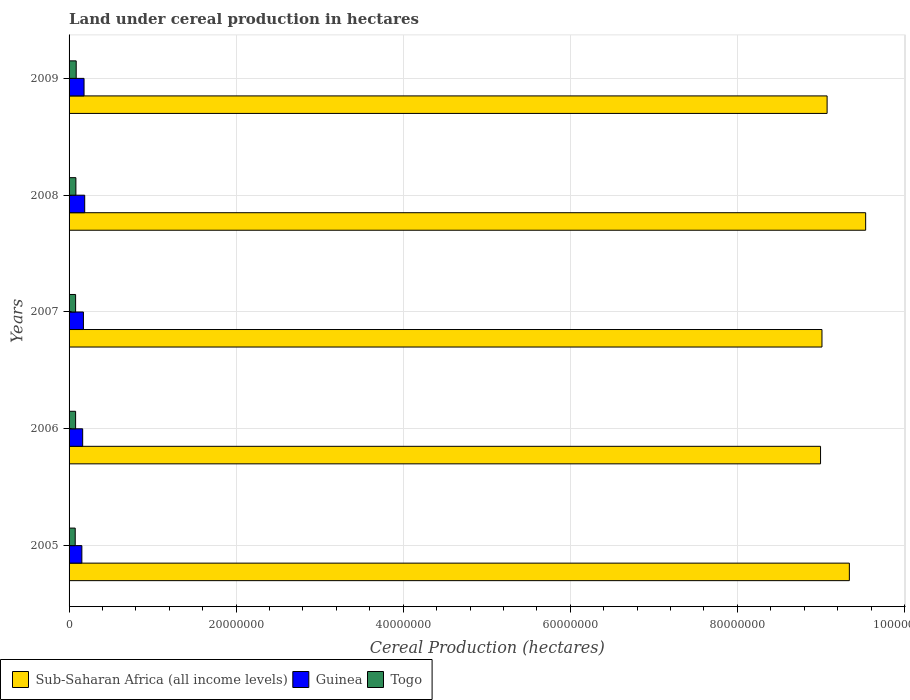How many groups of bars are there?
Your response must be concise. 5. Are the number of bars per tick equal to the number of legend labels?
Your answer should be very brief. Yes. Are the number of bars on each tick of the Y-axis equal?
Provide a short and direct response. Yes. How many bars are there on the 5th tick from the top?
Make the answer very short. 3. What is the land under cereal production in Sub-Saharan Africa (all income levels) in 2006?
Make the answer very short. 9.00e+07. Across all years, what is the maximum land under cereal production in Sub-Saharan Africa (all income levels)?
Your response must be concise. 9.54e+07. Across all years, what is the minimum land under cereal production in Guinea?
Give a very brief answer. 1.53e+06. In which year was the land under cereal production in Guinea maximum?
Your answer should be very brief. 2008. What is the total land under cereal production in Togo in the graph?
Your answer should be compact. 3.97e+06. What is the difference between the land under cereal production in Sub-Saharan Africa (all income levels) in 2007 and that in 2008?
Your answer should be very brief. -5.23e+06. What is the difference between the land under cereal production in Guinea in 2006 and the land under cereal production in Sub-Saharan Africa (all income levels) in 2009?
Your answer should be compact. -8.91e+07. What is the average land under cereal production in Guinea per year?
Ensure brevity in your answer.  1.71e+06. In the year 2005, what is the difference between the land under cereal production in Togo and land under cereal production in Guinea?
Provide a short and direct response. -7.95e+05. In how many years, is the land under cereal production in Guinea greater than 88000000 hectares?
Ensure brevity in your answer.  0. What is the ratio of the land under cereal production in Togo in 2005 to that in 2009?
Ensure brevity in your answer.  0.86. What is the difference between the highest and the second highest land under cereal production in Sub-Saharan Africa (all income levels)?
Ensure brevity in your answer.  1.95e+06. What is the difference between the highest and the lowest land under cereal production in Togo?
Keep it short and to the point. 1.18e+05. Is the sum of the land under cereal production in Togo in 2005 and 2008 greater than the maximum land under cereal production in Guinea across all years?
Ensure brevity in your answer.  No. What does the 3rd bar from the top in 2006 represents?
Give a very brief answer. Sub-Saharan Africa (all income levels). What does the 2nd bar from the bottom in 2006 represents?
Your answer should be compact. Guinea. How many years are there in the graph?
Provide a succinct answer. 5. Does the graph contain grids?
Provide a short and direct response. Yes. Where does the legend appear in the graph?
Make the answer very short. Bottom left. How are the legend labels stacked?
Offer a very short reply. Horizontal. What is the title of the graph?
Offer a terse response. Land under cereal production in hectares. Does "Romania" appear as one of the legend labels in the graph?
Make the answer very short. No. What is the label or title of the X-axis?
Provide a succinct answer. Cereal Production (hectares). What is the Cereal Production (hectares) of Sub-Saharan Africa (all income levels) in 2005?
Give a very brief answer. 9.34e+07. What is the Cereal Production (hectares) in Guinea in 2005?
Give a very brief answer. 1.53e+06. What is the Cereal Production (hectares) of Togo in 2005?
Offer a terse response. 7.36e+05. What is the Cereal Production (hectares) of Sub-Saharan Africa (all income levels) in 2006?
Keep it short and to the point. 9.00e+07. What is the Cereal Production (hectares) in Guinea in 2006?
Your response must be concise. 1.63e+06. What is the Cereal Production (hectares) in Togo in 2006?
Provide a short and direct response. 7.83e+05. What is the Cereal Production (hectares) in Sub-Saharan Africa (all income levels) in 2007?
Your answer should be very brief. 9.01e+07. What is the Cereal Production (hectares) in Guinea in 2007?
Offer a very short reply. 1.72e+06. What is the Cereal Production (hectares) in Togo in 2007?
Provide a succinct answer. 7.82e+05. What is the Cereal Production (hectares) of Sub-Saharan Africa (all income levels) in 2008?
Your response must be concise. 9.54e+07. What is the Cereal Production (hectares) of Guinea in 2008?
Your answer should be very brief. 1.87e+06. What is the Cereal Production (hectares) of Togo in 2008?
Your answer should be very brief. 8.17e+05. What is the Cereal Production (hectares) of Sub-Saharan Africa (all income levels) in 2009?
Your response must be concise. 9.07e+07. What is the Cereal Production (hectares) in Guinea in 2009?
Your answer should be compact. 1.79e+06. What is the Cereal Production (hectares) of Togo in 2009?
Give a very brief answer. 8.54e+05. Across all years, what is the maximum Cereal Production (hectares) of Sub-Saharan Africa (all income levels)?
Ensure brevity in your answer.  9.54e+07. Across all years, what is the maximum Cereal Production (hectares) of Guinea?
Your answer should be compact. 1.87e+06. Across all years, what is the maximum Cereal Production (hectares) of Togo?
Give a very brief answer. 8.54e+05. Across all years, what is the minimum Cereal Production (hectares) of Sub-Saharan Africa (all income levels)?
Your answer should be compact. 9.00e+07. Across all years, what is the minimum Cereal Production (hectares) of Guinea?
Give a very brief answer. 1.53e+06. Across all years, what is the minimum Cereal Production (hectares) in Togo?
Offer a very short reply. 7.36e+05. What is the total Cereal Production (hectares) in Sub-Saharan Africa (all income levels) in the graph?
Your answer should be compact. 4.60e+08. What is the total Cereal Production (hectares) of Guinea in the graph?
Offer a very short reply. 8.54e+06. What is the total Cereal Production (hectares) of Togo in the graph?
Your answer should be very brief. 3.97e+06. What is the difference between the Cereal Production (hectares) of Sub-Saharan Africa (all income levels) in 2005 and that in 2006?
Give a very brief answer. 3.45e+06. What is the difference between the Cereal Production (hectares) of Guinea in 2005 and that in 2006?
Make the answer very short. -9.67e+04. What is the difference between the Cereal Production (hectares) of Togo in 2005 and that in 2006?
Ensure brevity in your answer.  -4.74e+04. What is the difference between the Cereal Production (hectares) of Sub-Saharan Africa (all income levels) in 2005 and that in 2007?
Keep it short and to the point. 3.28e+06. What is the difference between the Cereal Production (hectares) in Guinea in 2005 and that in 2007?
Your answer should be compact. -1.87e+05. What is the difference between the Cereal Production (hectares) of Togo in 2005 and that in 2007?
Give a very brief answer. -4.67e+04. What is the difference between the Cereal Production (hectares) in Sub-Saharan Africa (all income levels) in 2005 and that in 2008?
Provide a succinct answer. -1.95e+06. What is the difference between the Cereal Production (hectares) in Guinea in 2005 and that in 2008?
Keep it short and to the point. -3.41e+05. What is the difference between the Cereal Production (hectares) of Togo in 2005 and that in 2008?
Your response must be concise. -8.14e+04. What is the difference between the Cereal Production (hectares) of Sub-Saharan Africa (all income levels) in 2005 and that in 2009?
Provide a succinct answer. 2.66e+06. What is the difference between the Cereal Production (hectares) of Guinea in 2005 and that in 2009?
Your response must be concise. -2.61e+05. What is the difference between the Cereal Production (hectares) in Togo in 2005 and that in 2009?
Your response must be concise. -1.18e+05. What is the difference between the Cereal Production (hectares) of Sub-Saharan Africa (all income levels) in 2006 and that in 2007?
Keep it short and to the point. -1.70e+05. What is the difference between the Cereal Production (hectares) of Guinea in 2006 and that in 2007?
Provide a succinct answer. -9.02e+04. What is the difference between the Cereal Production (hectares) of Togo in 2006 and that in 2007?
Provide a short and direct response. 667. What is the difference between the Cereal Production (hectares) in Sub-Saharan Africa (all income levels) in 2006 and that in 2008?
Provide a short and direct response. -5.40e+06. What is the difference between the Cereal Production (hectares) in Guinea in 2006 and that in 2008?
Make the answer very short. -2.44e+05. What is the difference between the Cereal Production (hectares) in Togo in 2006 and that in 2008?
Your response must be concise. -3.40e+04. What is the difference between the Cereal Production (hectares) in Sub-Saharan Africa (all income levels) in 2006 and that in 2009?
Your response must be concise. -7.85e+05. What is the difference between the Cereal Production (hectares) of Guinea in 2006 and that in 2009?
Your answer should be very brief. -1.64e+05. What is the difference between the Cereal Production (hectares) of Togo in 2006 and that in 2009?
Offer a very short reply. -7.08e+04. What is the difference between the Cereal Production (hectares) of Sub-Saharan Africa (all income levels) in 2007 and that in 2008?
Offer a very short reply. -5.23e+06. What is the difference between the Cereal Production (hectares) of Guinea in 2007 and that in 2008?
Your answer should be very brief. -1.54e+05. What is the difference between the Cereal Production (hectares) in Togo in 2007 and that in 2008?
Ensure brevity in your answer.  -3.47e+04. What is the difference between the Cereal Production (hectares) of Sub-Saharan Africa (all income levels) in 2007 and that in 2009?
Provide a succinct answer. -6.15e+05. What is the difference between the Cereal Production (hectares) of Guinea in 2007 and that in 2009?
Your response must be concise. -7.39e+04. What is the difference between the Cereal Production (hectares) in Togo in 2007 and that in 2009?
Ensure brevity in your answer.  -7.15e+04. What is the difference between the Cereal Production (hectares) in Sub-Saharan Africa (all income levels) in 2008 and that in 2009?
Make the answer very short. 4.62e+06. What is the difference between the Cereal Production (hectares) in Guinea in 2008 and that in 2009?
Your answer should be very brief. 7.99e+04. What is the difference between the Cereal Production (hectares) in Togo in 2008 and that in 2009?
Provide a short and direct response. -3.68e+04. What is the difference between the Cereal Production (hectares) in Sub-Saharan Africa (all income levels) in 2005 and the Cereal Production (hectares) in Guinea in 2006?
Give a very brief answer. 9.18e+07. What is the difference between the Cereal Production (hectares) in Sub-Saharan Africa (all income levels) in 2005 and the Cereal Production (hectares) in Togo in 2006?
Ensure brevity in your answer.  9.26e+07. What is the difference between the Cereal Production (hectares) of Guinea in 2005 and the Cereal Production (hectares) of Togo in 2006?
Your answer should be compact. 7.48e+05. What is the difference between the Cereal Production (hectares) in Sub-Saharan Africa (all income levels) in 2005 and the Cereal Production (hectares) in Guinea in 2007?
Your answer should be very brief. 9.17e+07. What is the difference between the Cereal Production (hectares) in Sub-Saharan Africa (all income levels) in 2005 and the Cereal Production (hectares) in Togo in 2007?
Provide a succinct answer. 9.26e+07. What is the difference between the Cereal Production (hectares) in Guinea in 2005 and the Cereal Production (hectares) in Togo in 2007?
Give a very brief answer. 7.49e+05. What is the difference between the Cereal Production (hectares) in Sub-Saharan Africa (all income levels) in 2005 and the Cereal Production (hectares) in Guinea in 2008?
Ensure brevity in your answer.  9.15e+07. What is the difference between the Cereal Production (hectares) of Sub-Saharan Africa (all income levels) in 2005 and the Cereal Production (hectares) of Togo in 2008?
Your answer should be compact. 9.26e+07. What is the difference between the Cereal Production (hectares) in Guinea in 2005 and the Cereal Production (hectares) in Togo in 2008?
Keep it short and to the point. 7.14e+05. What is the difference between the Cereal Production (hectares) of Sub-Saharan Africa (all income levels) in 2005 and the Cereal Production (hectares) of Guinea in 2009?
Ensure brevity in your answer.  9.16e+07. What is the difference between the Cereal Production (hectares) of Sub-Saharan Africa (all income levels) in 2005 and the Cereal Production (hectares) of Togo in 2009?
Ensure brevity in your answer.  9.26e+07. What is the difference between the Cereal Production (hectares) in Guinea in 2005 and the Cereal Production (hectares) in Togo in 2009?
Ensure brevity in your answer.  6.77e+05. What is the difference between the Cereal Production (hectares) of Sub-Saharan Africa (all income levels) in 2006 and the Cereal Production (hectares) of Guinea in 2007?
Ensure brevity in your answer.  8.82e+07. What is the difference between the Cereal Production (hectares) in Sub-Saharan Africa (all income levels) in 2006 and the Cereal Production (hectares) in Togo in 2007?
Ensure brevity in your answer.  8.92e+07. What is the difference between the Cereal Production (hectares) of Guinea in 2006 and the Cereal Production (hectares) of Togo in 2007?
Give a very brief answer. 8.45e+05. What is the difference between the Cereal Production (hectares) of Sub-Saharan Africa (all income levels) in 2006 and the Cereal Production (hectares) of Guinea in 2008?
Ensure brevity in your answer.  8.81e+07. What is the difference between the Cereal Production (hectares) of Sub-Saharan Africa (all income levels) in 2006 and the Cereal Production (hectares) of Togo in 2008?
Give a very brief answer. 8.91e+07. What is the difference between the Cereal Production (hectares) in Guinea in 2006 and the Cereal Production (hectares) in Togo in 2008?
Your answer should be very brief. 8.11e+05. What is the difference between the Cereal Production (hectares) of Sub-Saharan Africa (all income levels) in 2006 and the Cereal Production (hectares) of Guinea in 2009?
Provide a succinct answer. 8.82e+07. What is the difference between the Cereal Production (hectares) in Sub-Saharan Africa (all income levels) in 2006 and the Cereal Production (hectares) in Togo in 2009?
Provide a short and direct response. 8.91e+07. What is the difference between the Cereal Production (hectares) of Guinea in 2006 and the Cereal Production (hectares) of Togo in 2009?
Provide a succinct answer. 7.74e+05. What is the difference between the Cereal Production (hectares) of Sub-Saharan Africa (all income levels) in 2007 and the Cereal Production (hectares) of Guinea in 2008?
Make the answer very short. 8.83e+07. What is the difference between the Cereal Production (hectares) of Sub-Saharan Africa (all income levels) in 2007 and the Cereal Production (hectares) of Togo in 2008?
Offer a very short reply. 8.93e+07. What is the difference between the Cereal Production (hectares) in Guinea in 2007 and the Cereal Production (hectares) in Togo in 2008?
Ensure brevity in your answer.  9.01e+05. What is the difference between the Cereal Production (hectares) of Sub-Saharan Africa (all income levels) in 2007 and the Cereal Production (hectares) of Guinea in 2009?
Your response must be concise. 8.83e+07. What is the difference between the Cereal Production (hectares) of Sub-Saharan Africa (all income levels) in 2007 and the Cereal Production (hectares) of Togo in 2009?
Your response must be concise. 8.93e+07. What is the difference between the Cereal Production (hectares) of Guinea in 2007 and the Cereal Production (hectares) of Togo in 2009?
Offer a terse response. 8.64e+05. What is the difference between the Cereal Production (hectares) of Sub-Saharan Africa (all income levels) in 2008 and the Cereal Production (hectares) of Guinea in 2009?
Your response must be concise. 9.36e+07. What is the difference between the Cereal Production (hectares) of Sub-Saharan Africa (all income levels) in 2008 and the Cereal Production (hectares) of Togo in 2009?
Offer a terse response. 9.45e+07. What is the difference between the Cereal Production (hectares) of Guinea in 2008 and the Cereal Production (hectares) of Togo in 2009?
Offer a terse response. 1.02e+06. What is the average Cereal Production (hectares) in Sub-Saharan Africa (all income levels) per year?
Offer a terse response. 9.19e+07. What is the average Cereal Production (hectares) of Guinea per year?
Offer a terse response. 1.71e+06. What is the average Cereal Production (hectares) of Togo per year?
Make the answer very short. 7.95e+05. In the year 2005, what is the difference between the Cereal Production (hectares) of Sub-Saharan Africa (all income levels) and Cereal Production (hectares) of Guinea?
Your response must be concise. 9.19e+07. In the year 2005, what is the difference between the Cereal Production (hectares) in Sub-Saharan Africa (all income levels) and Cereal Production (hectares) in Togo?
Keep it short and to the point. 9.27e+07. In the year 2005, what is the difference between the Cereal Production (hectares) of Guinea and Cereal Production (hectares) of Togo?
Your answer should be compact. 7.95e+05. In the year 2006, what is the difference between the Cereal Production (hectares) in Sub-Saharan Africa (all income levels) and Cereal Production (hectares) in Guinea?
Provide a short and direct response. 8.83e+07. In the year 2006, what is the difference between the Cereal Production (hectares) of Sub-Saharan Africa (all income levels) and Cereal Production (hectares) of Togo?
Ensure brevity in your answer.  8.92e+07. In the year 2006, what is the difference between the Cereal Production (hectares) in Guinea and Cereal Production (hectares) in Togo?
Keep it short and to the point. 8.45e+05. In the year 2007, what is the difference between the Cereal Production (hectares) of Sub-Saharan Africa (all income levels) and Cereal Production (hectares) of Guinea?
Keep it short and to the point. 8.84e+07. In the year 2007, what is the difference between the Cereal Production (hectares) of Sub-Saharan Africa (all income levels) and Cereal Production (hectares) of Togo?
Give a very brief answer. 8.93e+07. In the year 2007, what is the difference between the Cereal Production (hectares) of Guinea and Cereal Production (hectares) of Togo?
Your answer should be very brief. 9.36e+05. In the year 2008, what is the difference between the Cereal Production (hectares) of Sub-Saharan Africa (all income levels) and Cereal Production (hectares) of Guinea?
Your answer should be compact. 9.35e+07. In the year 2008, what is the difference between the Cereal Production (hectares) of Sub-Saharan Africa (all income levels) and Cereal Production (hectares) of Togo?
Your answer should be very brief. 9.45e+07. In the year 2008, what is the difference between the Cereal Production (hectares) in Guinea and Cereal Production (hectares) in Togo?
Offer a terse response. 1.05e+06. In the year 2009, what is the difference between the Cereal Production (hectares) of Sub-Saharan Africa (all income levels) and Cereal Production (hectares) of Guinea?
Provide a succinct answer. 8.89e+07. In the year 2009, what is the difference between the Cereal Production (hectares) in Sub-Saharan Africa (all income levels) and Cereal Production (hectares) in Togo?
Your response must be concise. 8.99e+07. In the year 2009, what is the difference between the Cereal Production (hectares) of Guinea and Cereal Production (hectares) of Togo?
Give a very brief answer. 9.38e+05. What is the ratio of the Cereal Production (hectares) in Sub-Saharan Africa (all income levels) in 2005 to that in 2006?
Your answer should be very brief. 1.04. What is the ratio of the Cereal Production (hectares) in Guinea in 2005 to that in 2006?
Keep it short and to the point. 0.94. What is the ratio of the Cereal Production (hectares) in Togo in 2005 to that in 2006?
Your response must be concise. 0.94. What is the ratio of the Cereal Production (hectares) in Sub-Saharan Africa (all income levels) in 2005 to that in 2007?
Offer a terse response. 1.04. What is the ratio of the Cereal Production (hectares) of Guinea in 2005 to that in 2007?
Your answer should be very brief. 0.89. What is the ratio of the Cereal Production (hectares) of Togo in 2005 to that in 2007?
Give a very brief answer. 0.94. What is the ratio of the Cereal Production (hectares) of Sub-Saharan Africa (all income levels) in 2005 to that in 2008?
Your response must be concise. 0.98. What is the ratio of the Cereal Production (hectares) of Guinea in 2005 to that in 2008?
Give a very brief answer. 0.82. What is the ratio of the Cereal Production (hectares) in Togo in 2005 to that in 2008?
Your answer should be very brief. 0.9. What is the ratio of the Cereal Production (hectares) in Sub-Saharan Africa (all income levels) in 2005 to that in 2009?
Offer a terse response. 1.03. What is the ratio of the Cereal Production (hectares) of Guinea in 2005 to that in 2009?
Offer a terse response. 0.85. What is the ratio of the Cereal Production (hectares) in Togo in 2005 to that in 2009?
Keep it short and to the point. 0.86. What is the ratio of the Cereal Production (hectares) of Sub-Saharan Africa (all income levels) in 2006 to that in 2007?
Give a very brief answer. 1. What is the ratio of the Cereal Production (hectares) of Guinea in 2006 to that in 2007?
Provide a succinct answer. 0.95. What is the ratio of the Cereal Production (hectares) of Sub-Saharan Africa (all income levels) in 2006 to that in 2008?
Your answer should be compact. 0.94. What is the ratio of the Cereal Production (hectares) in Guinea in 2006 to that in 2008?
Ensure brevity in your answer.  0.87. What is the ratio of the Cereal Production (hectares) in Togo in 2006 to that in 2008?
Offer a very short reply. 0.96. What is the ratio of the Cereal Production (hectares) in Guinea in 2006 to that in 2009?
Provide a succinct answer. 0.91. What is the ratio of the Cereal Production (hectares) in Togo in 2006 to that in 2009?
Provide a succinct answer. 0.92. What is the ratio of the Cereal Production (hectares) in Sub-Saharan Africa (all income levels) in 2007 to that in 2008?
Ensure brevity in your answer.  0.95. What is the ratio of the Cereal Production (hectares) of Guinea in 2007 to that in 2008?
Your answer should be compact. 0.92. What is the ratio of the Cereal Production (hectares) of Togo in 2007 to that in 2008?
Make the answer very short. 0.96. What is the ratio of the Cereal Production (hectares) in Guinea in 2007 to that in 2009?
Your answer should be compact. 0.96. What is the ratio of the Cereal Production (hectares) in Togo in 2007 to that in 2009?
Provide a short and direct response. 0.92. What is the ratio of the Cereal Production (hectares) in Sub-Saharan Africa (all income levels) in 2008 to that in 2009?
Your answer should be compact. 1.05. What is the ratio of the Cereal Production (hectares) of Guinea in 2008 to that in 2009?
Give a very brief answer. 1.04. What is the ratio of the Cereal Production (hectares) in Togo in 2008 to that in 2009?
Your answer should be very brief. 0.96. What is the difference between the highest and the second highest Cereal Production (hectares) in Sub-Saharan Africa (all income levels)?
Offer a very short reply. 1.95e+06. What is the difference between the highest and the second highest Cereal Production (hectares) of Guinea?
Make the answer very short. 7.99e+04. What is the difference between the highest and the second highest Cereal Production (hectares) of Togo?
Offer a very short reply. 3.68e+04. What is the difference between the highest and the lowest Cereal Production (hectares) in Sub-Saharan Africa (all income levels)?
Provide a succinct answer. 5.40e+06. What is the difference between the highest and the lowest Cereal Production (hectares) in Guinea?
Your response must be concise. 3.41e+05. What is the difference between the highest and the lowest Cereal Production (hectares) in Togo?
Your answer should be very brief. 1.18e+05. 